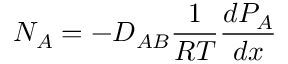<formula> <loc_0><loc_0><loc_500><loc_500>N _ { A } = - D _ { A B } { \frac { 1 } { R T } } { \frac { d P _ { A } } { d x } }</formula> 